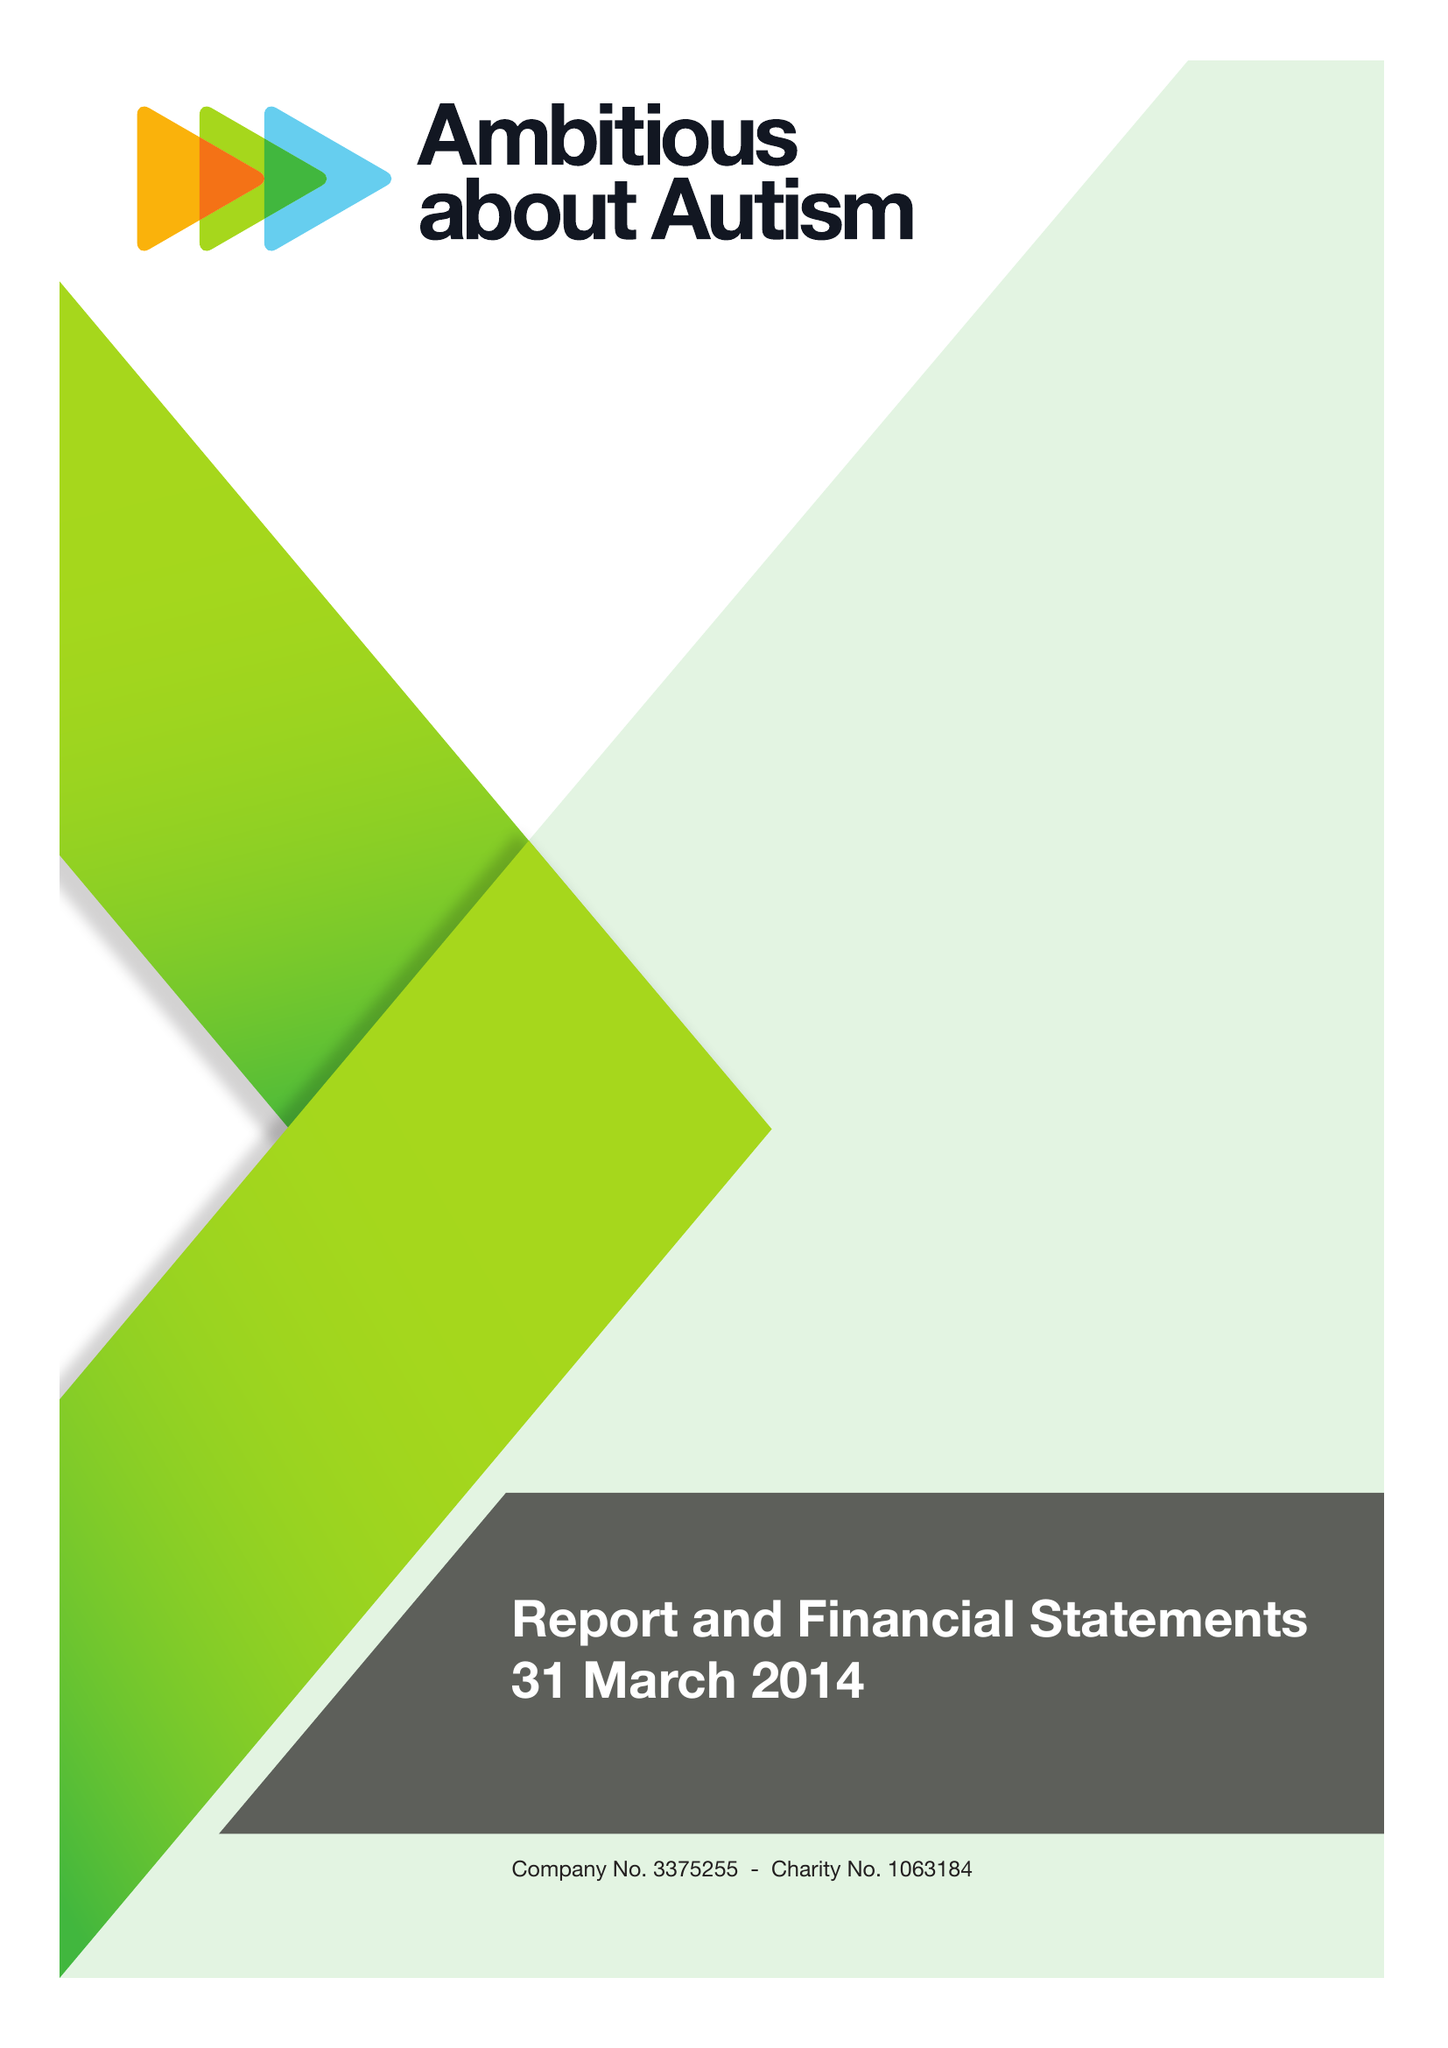What is the value for the address__street_line?
Answer the question using a single word or phrase. WOODSIDE AVENUE 